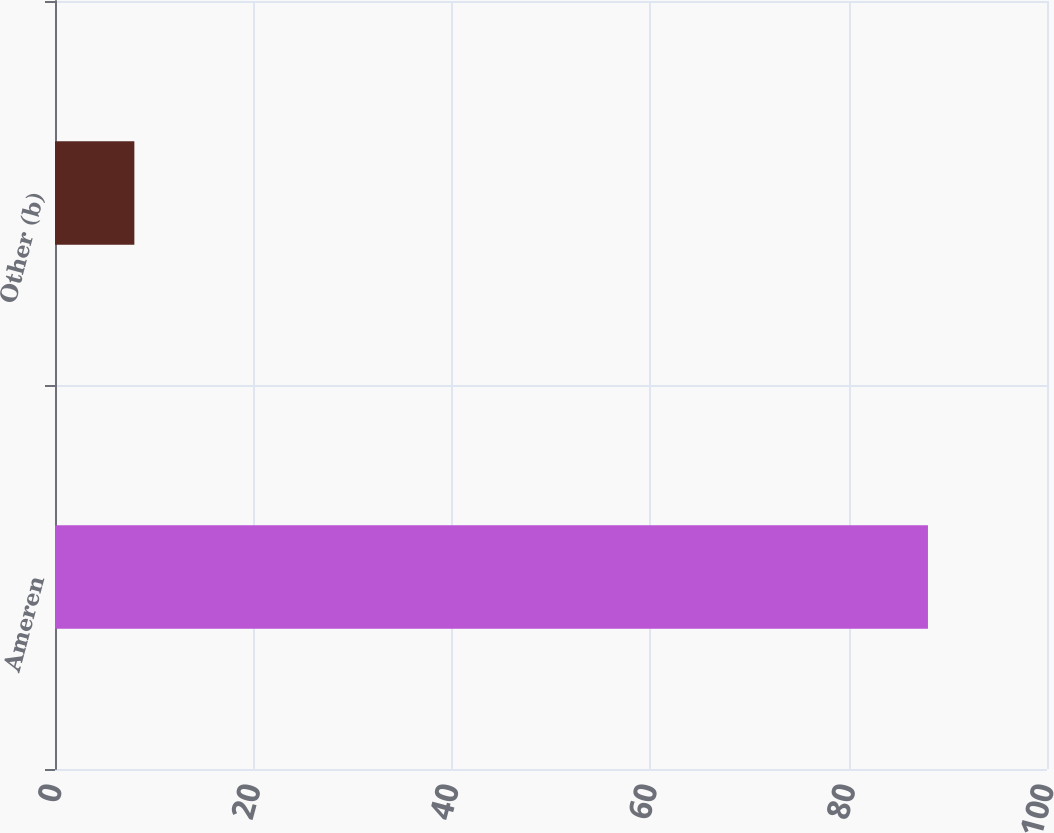Convert chart. <chart><loc_0><loc_0><loc_500><loc_500><bar_chart><fcel>Ameren<fcel>Other (b)<nl><fcel>88<fcel>8<nl></chart> 